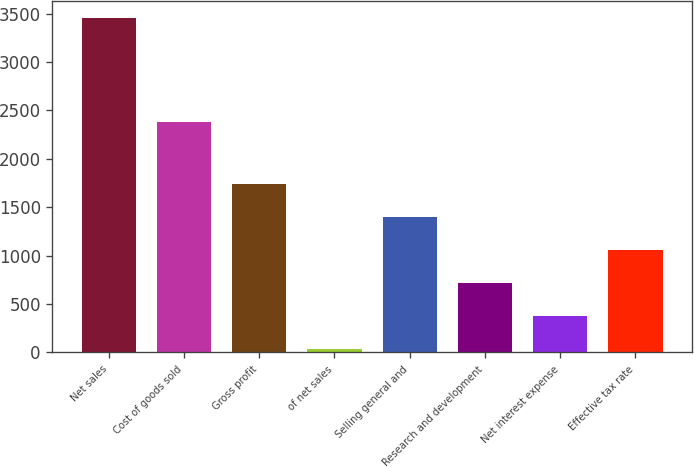Convert chart. <chart><loc_0><loc_0><loc_500><loc_500><bar_chart><fcel>Net sales<fcel>Cost of goods sold<fcel>Gross profit<fcel>of net sales<fcel>Selling general and<fcel>Research and development<fcel>Net interest expense<fcel>Effective tax rate<nl><fcel>3456.7<fcel>2383<fcel>1743.9<fcel>31.1<fcel>1401.34<fcel>716.22<fcel>373.66<fcel>1058.78<nl></chart> 